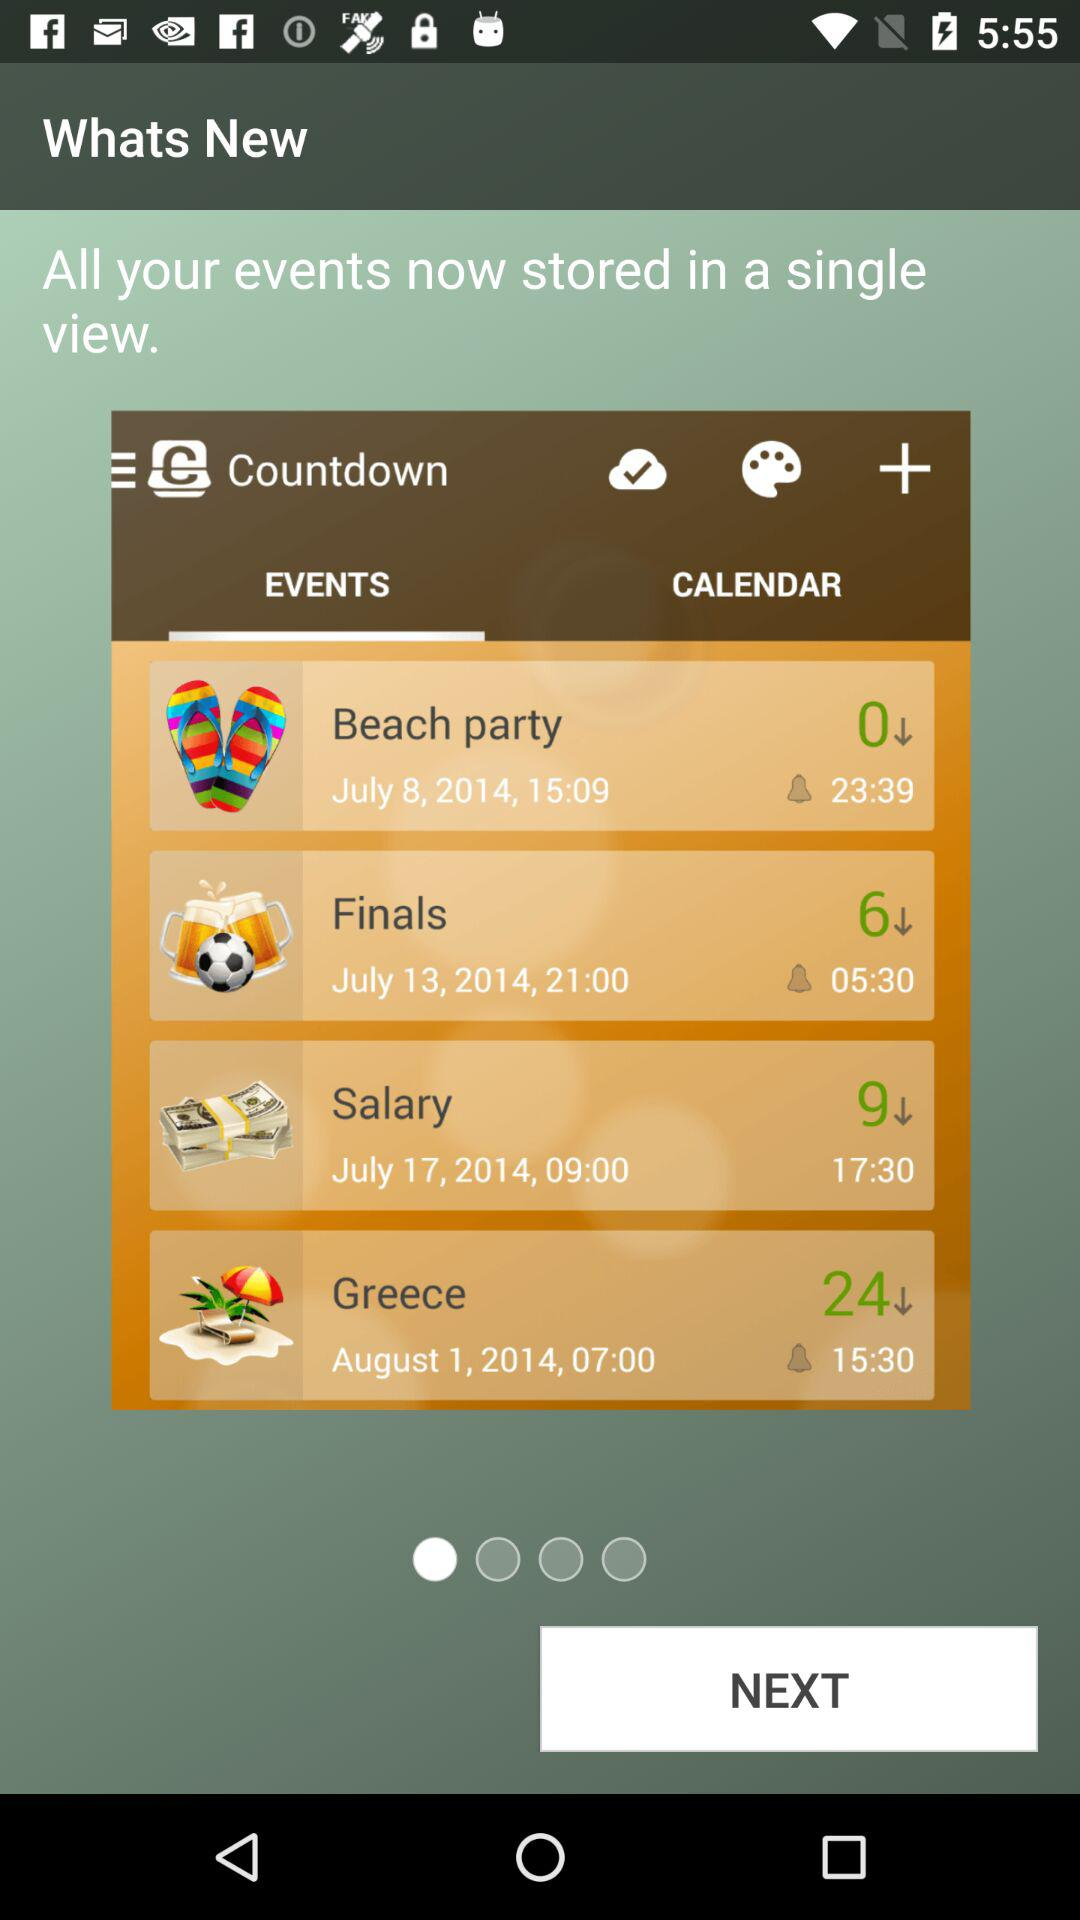What is the date of the salary? The date of the salary is July 17, 2014. 